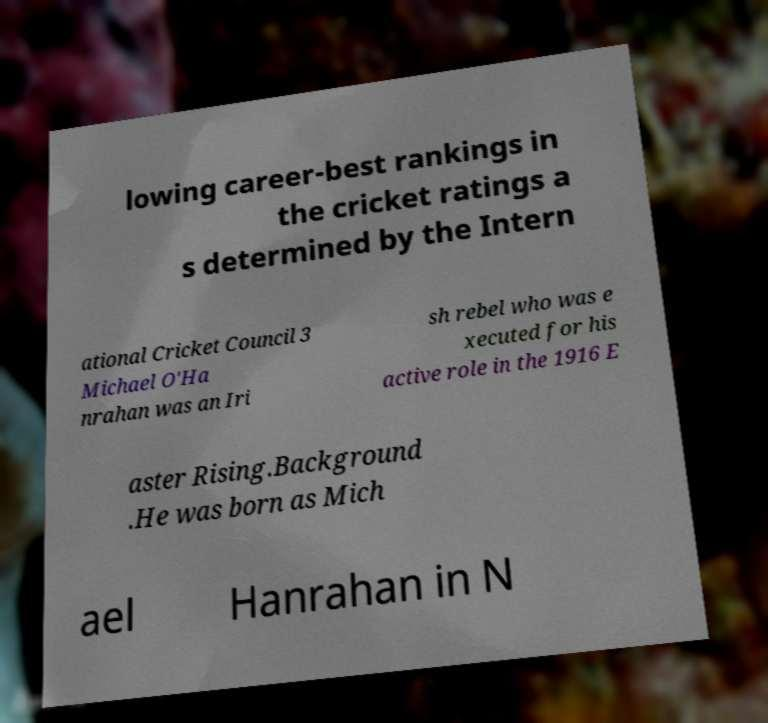Can you read and provide the text displayed in the image?This photo seems to have some interesting text. Can you extract and type it out for me? lowing career-best rankings in the cricket ratings a s determined by the Intern ational Cricket Council 3 Michael O'Ha nrahan was an Iri sh rebel who was e xecuted for his active role in the 1916 E aster Rising.Background .He was born as Mich ael Hanrahan in N 